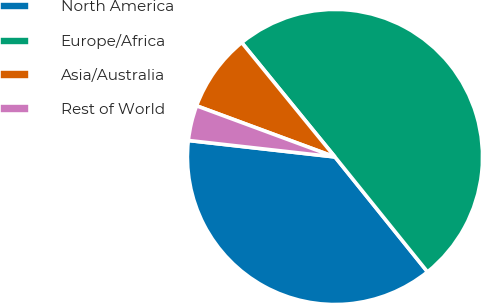Convert chart to OTSL. <chart><loc_0><loc_0><loc_500><loc_500><pie_chart><fcel>North America<fcel>Europe/Africa<fcel>Asia/Australia<fcel>Rest of World<nl><fcel>37.57%<fcel>50.1%<fcel>8.48%<fcel>3.85%<nl></chart> 